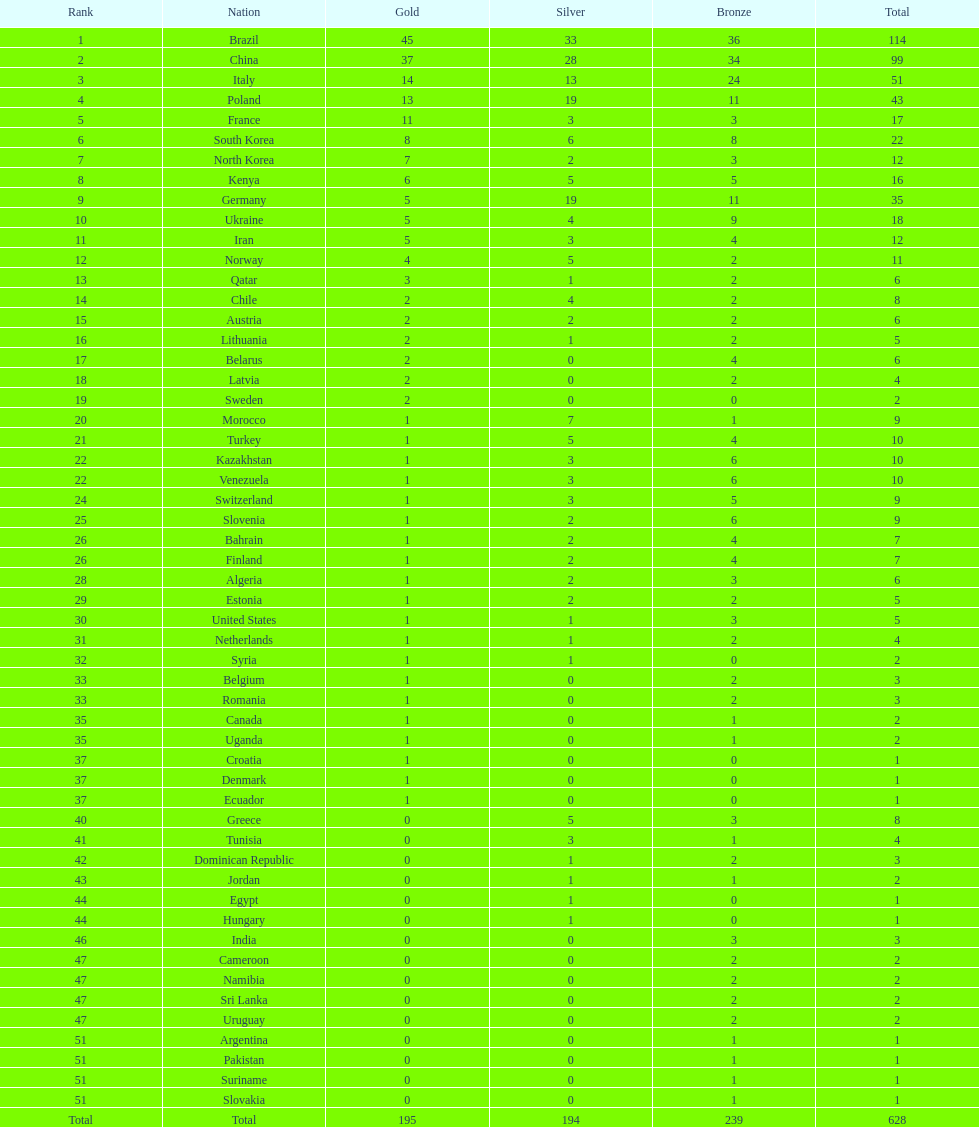South korea has how many more medals that north korea? 10. 